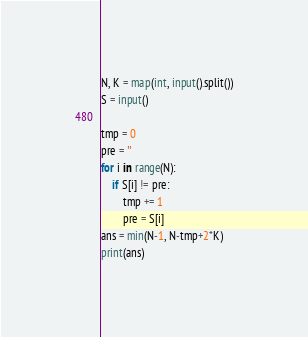Convert code to text. <code><loc_0><loc_0><loc_500><loc_500><_Python_>N, K = map(int, input().split())
S = input()

tmp = 0
pre = ''
for i in range(N):
    if S[i] != pre:
        tmp += 1
        pre = S[i]
ans = min(N-1, N-tmp+2*K)
print(ans)
</code> 